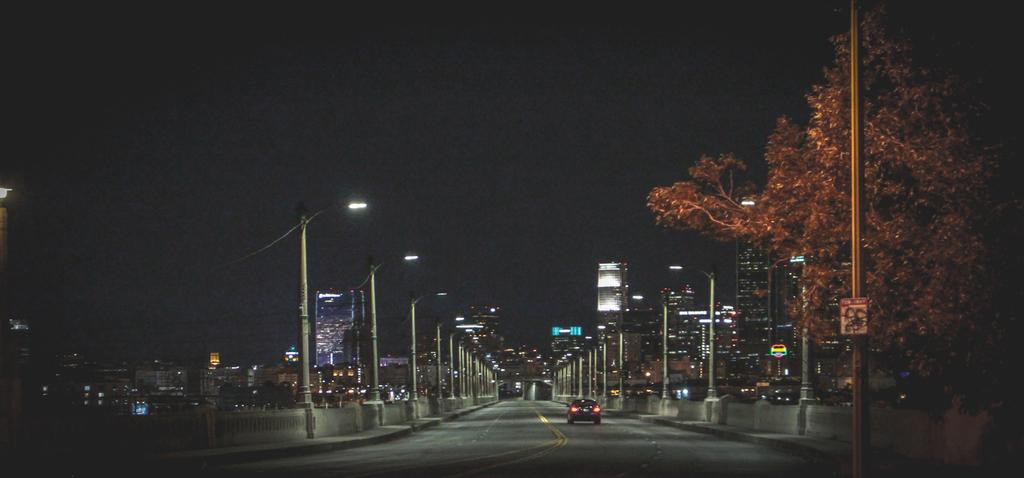What is on the road in the image? There is a vehicle on the road in the image. What can be seen beside the road? There are light poles beside the road. What is visible in the distance? There are buildings in the distance. What is on the right side of the image? There is a tree and a pole on the right side of the image. How many visitors are present in the image? There is no indication of any visitors in the image. What type of bead is hanging from the tree in the image? There is no bead present in the image; it only features a tree and a pole on the right side. 